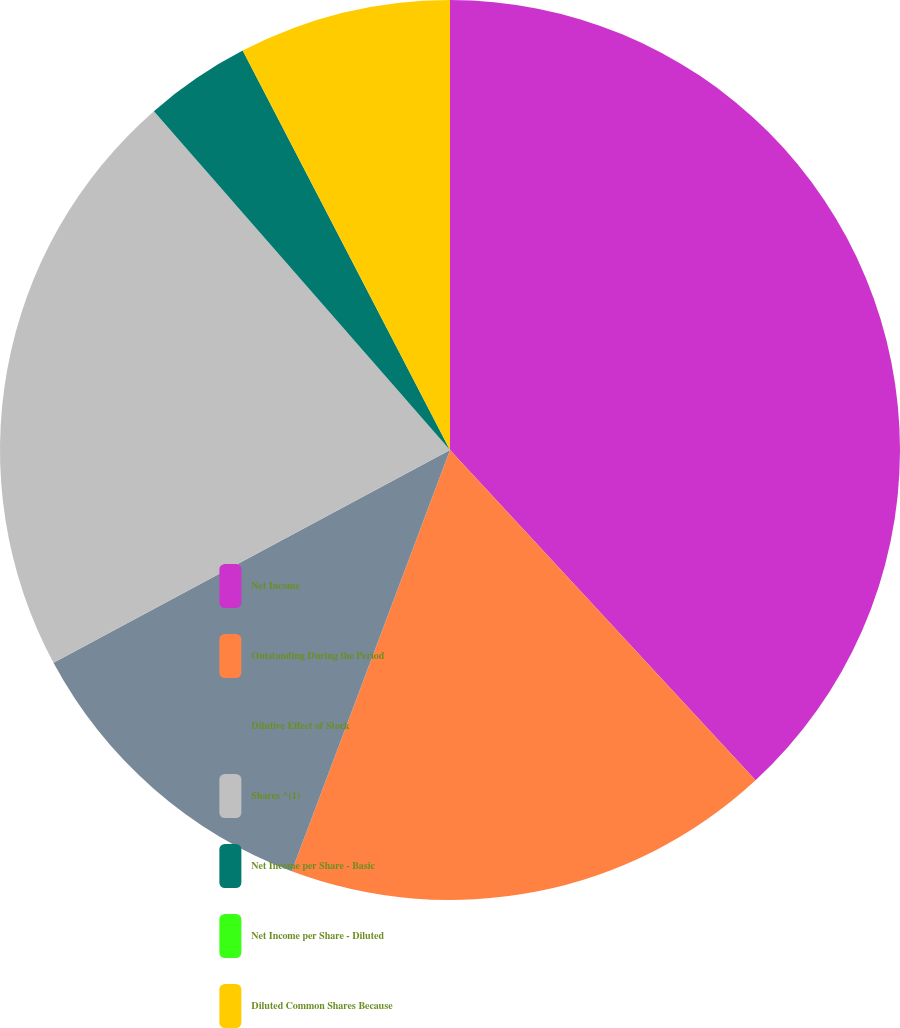Convert chart. <chart><loc_0><loc_0><loc_500><loc_500><pie_chart><fcel>Net Income<fcel>Outstanding During the Period<fcel>Dilutive Effect of Stock<fcel>Shares ^(1)<fcel>Net Income per Share - Basic<fcel>Net Income per Share - Diluted<fcel>Diluted Common Shares Because<nl><fcel>38.12%<fcel>17.6%<fcel>11.44%<fcel>21.41%<fcel>3.81%<fcel>0.0%<fcel>7.62%<nl></chart> 